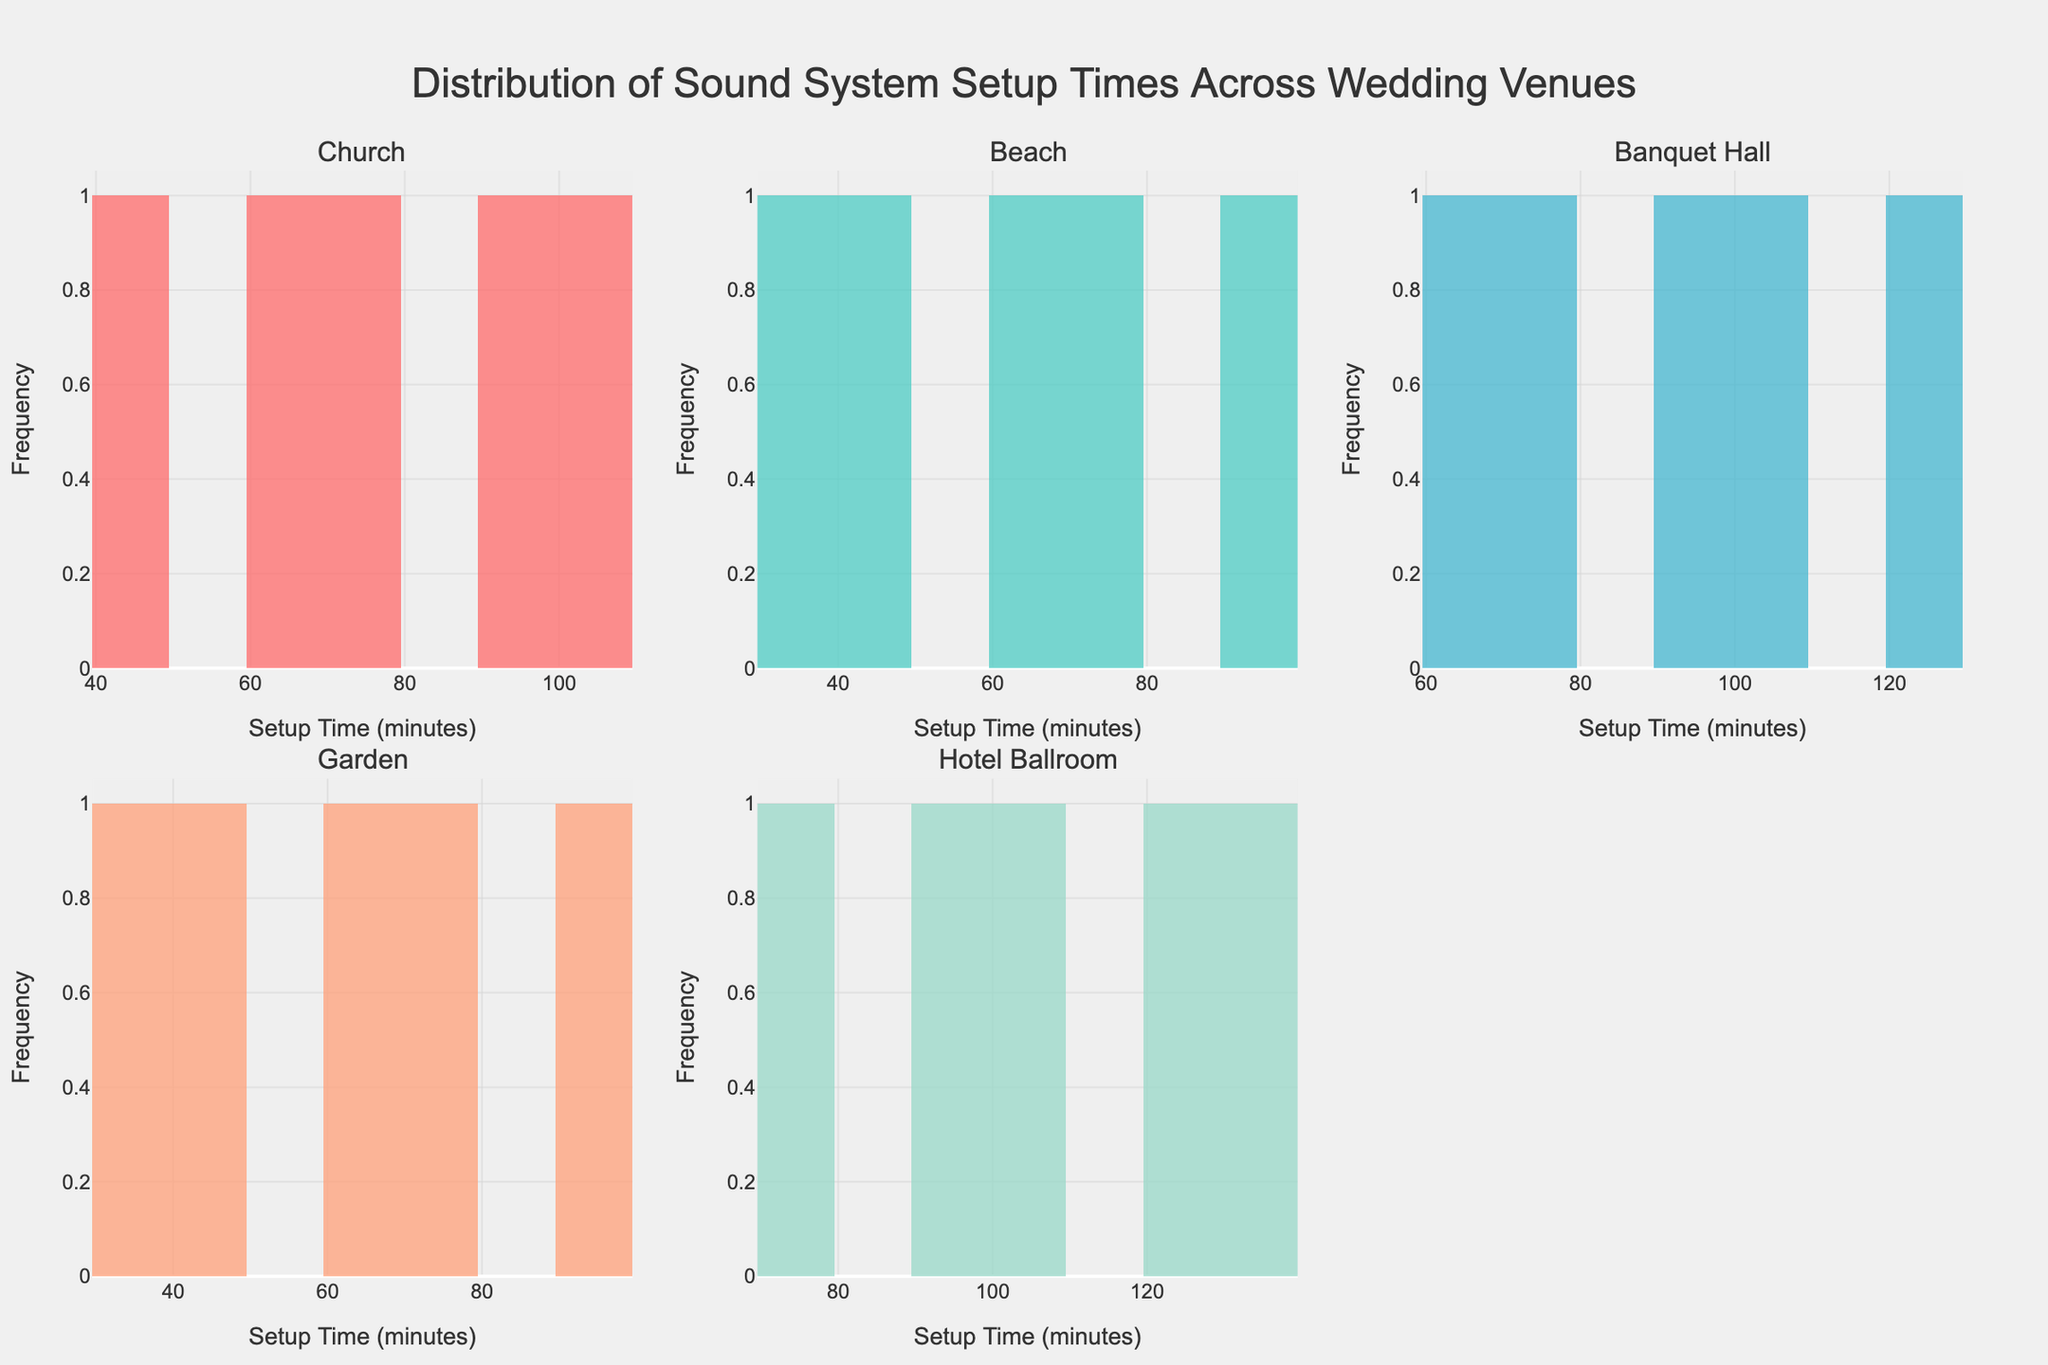How many different wedding venues are represented in the figure? The figure contains multiple subplots, each corresponding to a different wedding venue. Counting these subplots gives the total number of venues represented.
Answer: 5 What's the common setup time range across all venues? By glancing at the x-axes of all subplots, you can observe the range of setup times. They all start at 30 minutes and go up to 135 minutes.
Answer: 30-135 minutes Which venue shows the most frequent setup time range of 60-75 minutes? Looking at the histograms, the tallest bar in the 60-75 minutes range is in the "Garden" venue subplot. This indicates the highest frequency for this range.
Answer: Garden Compare the average setup time between the "Church" and "Hotel Ballroom" venues. Calculate the midpoint of each bar in the histograms and then average these midpoints. For instance, for the "Church," values are 45, 60, 75, 90, and 105. For "Hotel Ballroom," values are 75, 90, 105, 120, and 135.
Answer: Church: 75, Hotel Ballroom: 105 Which venue has the shortest setup times? By observing the leftmost histogram bars, the "Beach" and "Garden" venues start at 30 minutes being shorter than the minimum setup times for other venues.
Answer: Beach and Garden What is the most frequent setup time in the "Banquet Hall" venue? Check which bar has the highest frequency in the "Banquet Hall" subplot. The 75 minutes bar is the tallest.
Answer: 75 minutes Is there any venue where the setup time goes beyond 120 minutes? Look at the x-axes of each subplot for any histogram bar beyond 120 minutes. Only the "Hotel Ballroom" has a bar at 135 minutes.
Answer: Hotel Ballroom Which venue shows the highest variability in setup times? Assess the spread of the bars across the x-axis in each subplot. "Hotel Ballroom" spans from 75 to 135 minutes, indicating the highest variability.
Answer: Hotel Ballroom Determine the median setup time for the "Church" venue. Ordering the setup times for "Church" gives us: 45, 60, 75, 90, 105. The median value, being the middle value in this ordered list, is 75 minutes.
Answer: 75 minutes 